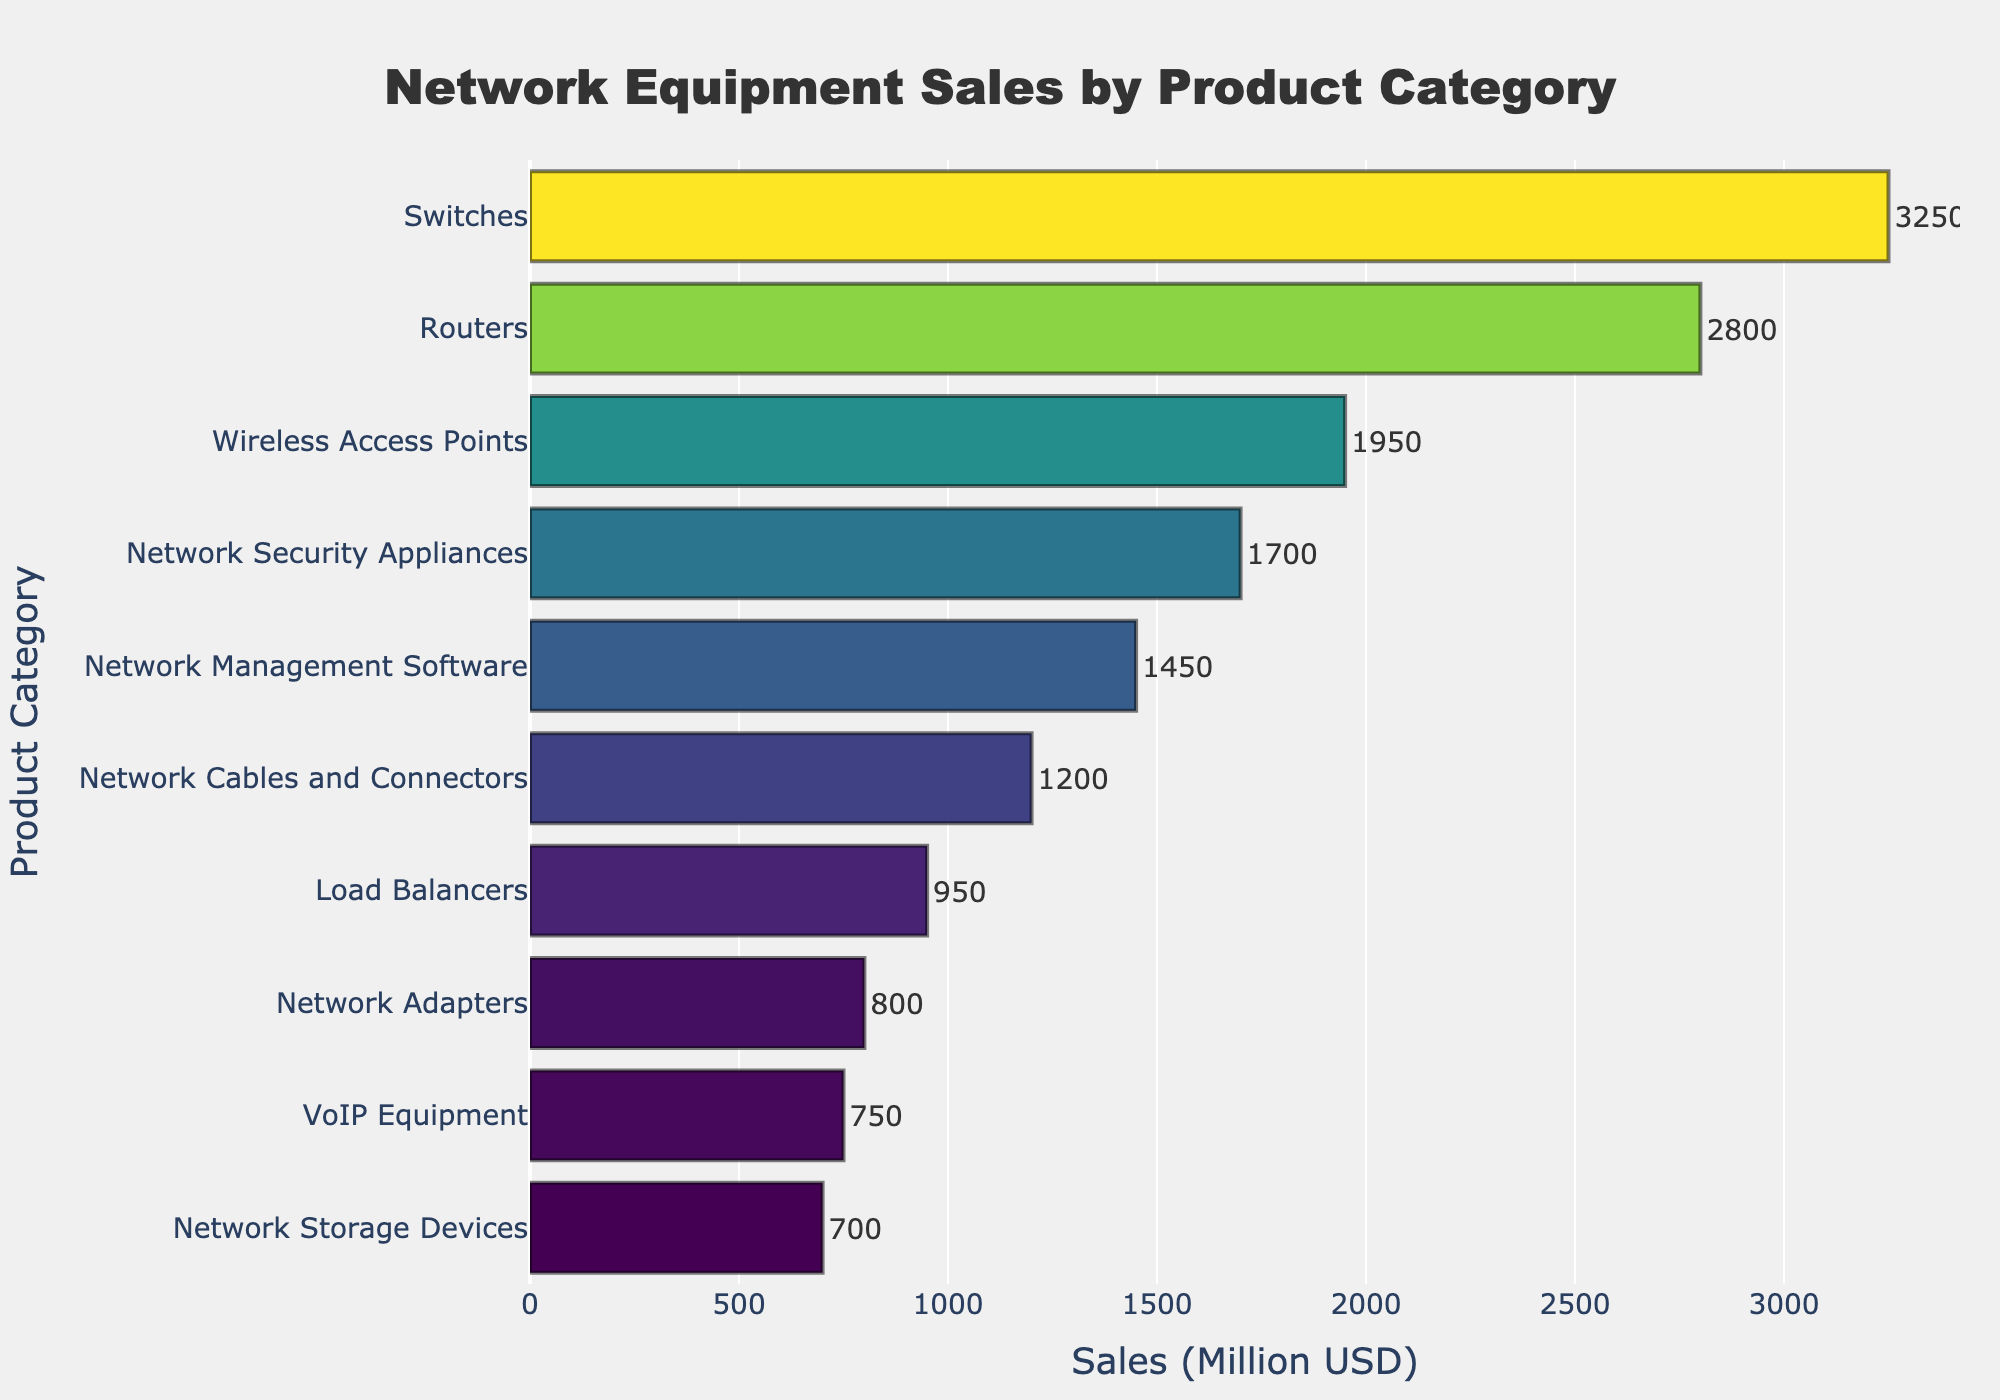Which product category has the highest sales? The bar representing "Switches" has the longest length, reaching the highest value on the sales axis.
Answer: Switches Which category has the lowest sales? The bar for "Network Storage Devices" is the shortest, corresponding to the lowest value on the sales axis.
Answer: Network Storage Devices What is the difference in sales between the top two categories? Subtract the sales of the second highest (Routers, 2800M USD) from the highest (Switches, 3250M USD). 3250 - 2800 = 450.
Answer: 450 How many categories have sales below 1500 Million USD? Count the bars whose sales values are below 1500 Million USD: Network Adapters, VoIP Equipment, and Network Storage Devices. This gives 3 categories.
Answer: 3 What is the average sales value of the categories with sales above 2000 Million USD? Sum the sales of "Switches" (3250M USD) and "Routers" (2800M USD) and divide by the number of categories. (3250 + 2800) / 2 = 3025M USD.
Answer: 3025 Which product category’s sales are closest to the median sales value? Arrange categories by sales, find the middle value. Middle value is found between 1450M USD (Network Management Software) and 1700M USD (Network Security Appliances). The median would be between those two values (around 1575M USD). The closest category is Network Security Appliances (1700M USD).
Answer: Network Security Appliances How much more does "Wireless Access Points" sell than "Network Cables and Connectors"? Subtract the sales of Network Cables and Connectors (1200M USD) from the sales of Wireless Access Points (1950M USD). 1950 - 1200 = 750.
Answer: 750 Which categories' bars fall in the middle range of the color scale used? The color scale ranges from dark for low values to bright for high values. Categories in the middle sales figures include Network Security Appliances, Network Management Software, and Network Cables and Connectors.
Answer: Network Security Appliances, Network Management Software, Network Cables and Connectors What combined sales do "Load Balancers" and "Network Adapters" account for? Add the sales of Load Balancers (950M USD) and Network Adapters (800M USD). 950 + 800 = 1750M USD.
Answer: 1750 Are the sales of "VoIP Equipment" closer to "Network Adapters" or "Network Storage Devices"? Calculate the difference from VoIP Equipment (750M USD) to Network Adapters (800M USD) and Network Storage Devices (700M USD). 800 - 750 = 50; 750 - 700 = 50. The differences are equal.
Answer: Both are equally close 